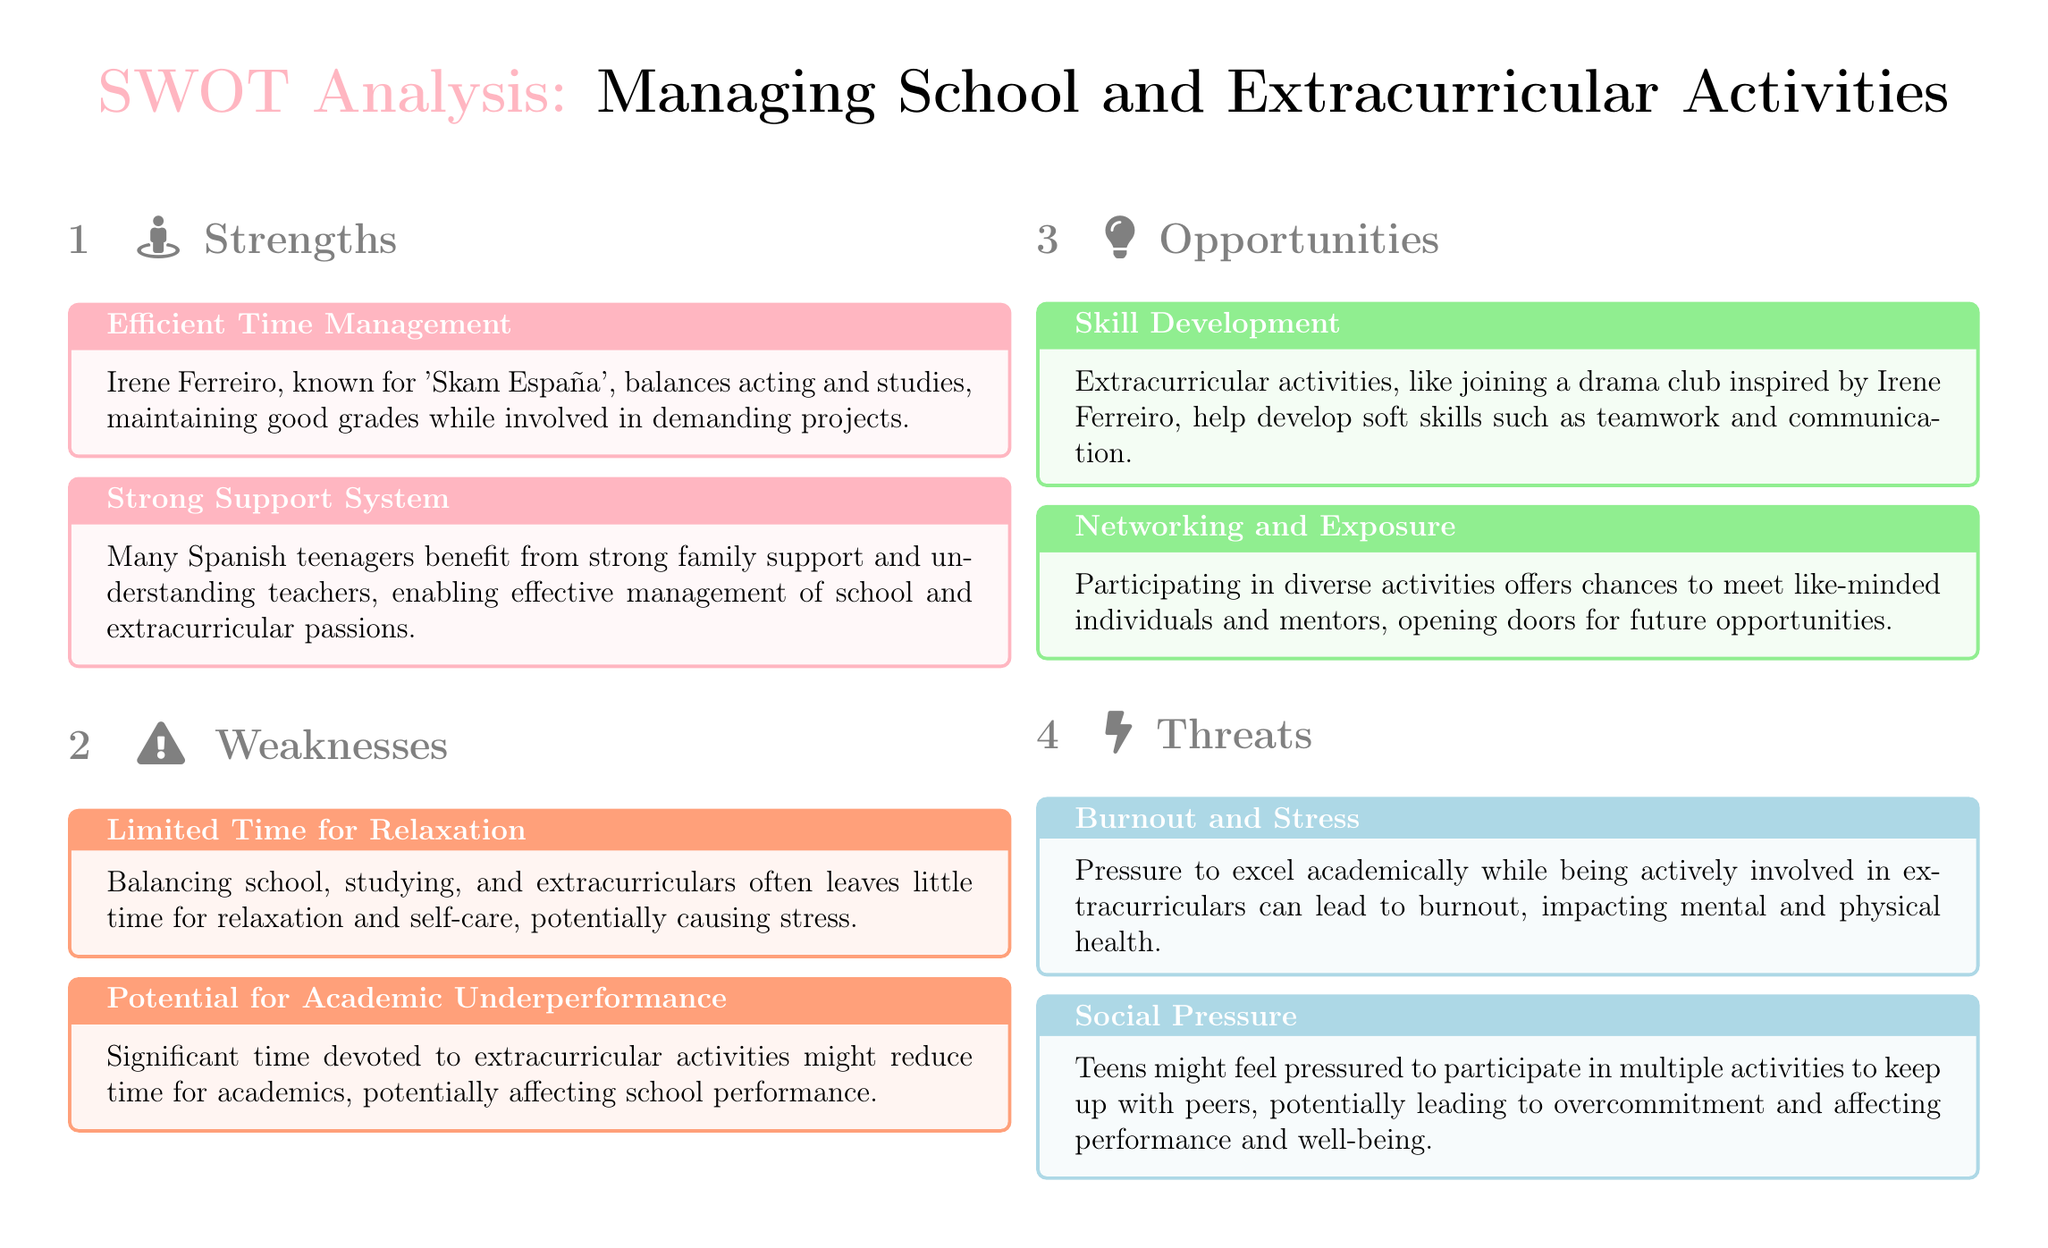What is the first strength listed? The first strength is about Efficient Time Management, which highlights Irene Ferreiro's ability to balance studies and acting.
Answer: Efficient Time Management What are the benefits of a Strong Support System? A Strong Support System can enable effective management of school and extracurricular passions through family and teacher support.
Answer: Effective management What is a weakness associated with limited free time? The weakness associated with limited free time is the lack of time for relaxation and self-care, potentially causing stress.
Answer: Stress How might extracurricular activities impact academic performance? Significant time devoted to extracurriculars can lead to academic underperformance due to reduced study time.
Answer: Academic underperformance What is one opportunity provided by extracurricular activities? One opportunity is Skill Development, which helps in developing teamwork and communication skills.
Answer: Skill Development How can participating in activities benefit social interaction? Participating offers chances to meet like-minded individuals and mentors, which enhances networking.
Answer: Networking What is a threat related to academic pressure? A threat related to academic pressure is Burnout and Stress, which can impact mental and physical health.
Answer: Burnout and Stress What social issue may teens face regarding extracurricular commitments? Teens may face Social Pressure to participate in multiple activities, leading to potential overcommitment.
Answer: Social Pressure What does the SWOT analysis structure consist of? The SWOT analysis structure consists of four sections: Strengths, Weaknesses, Opportunities, and Threats.
Answer: Four sections 